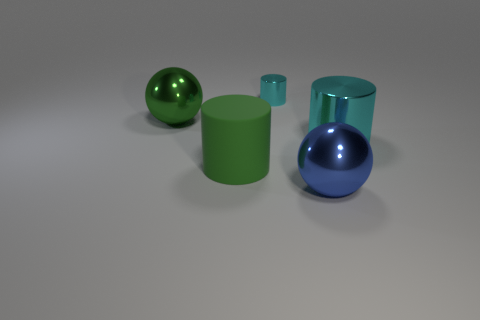Add 5 small red metal cylinders. How many objects exist? 10 Subtract all cylinders. How many objects are left? 2 Add 3 small objects. How many small objects exist? 4 Subtract 0 gray spheres. How many objects are left? 5 Subtract all small shiny things. Subtract all big cyan things. How many objects are left? 3 Add 3 big cyan objects. How many big cyan objects are left? 4 